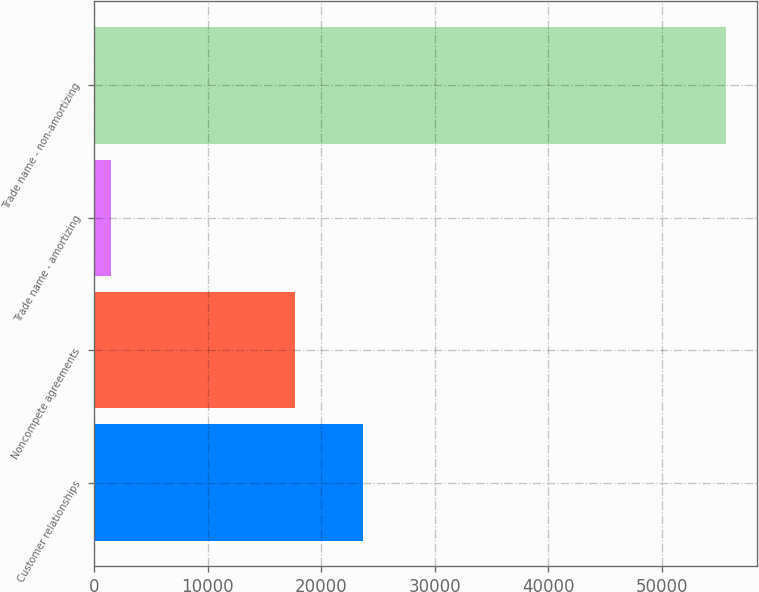<chart> <loc_0><loc_0><loc_500><loc_500><bar_chart><fcel>Customer relationships<fcel>Noncompete agreements<fcel>Trade name - amortizing<fcel>Trade name - non-amortizing<nl><fcel>23717<fcel>17677<fcel>1450<fcel>55637<nl></chart> 